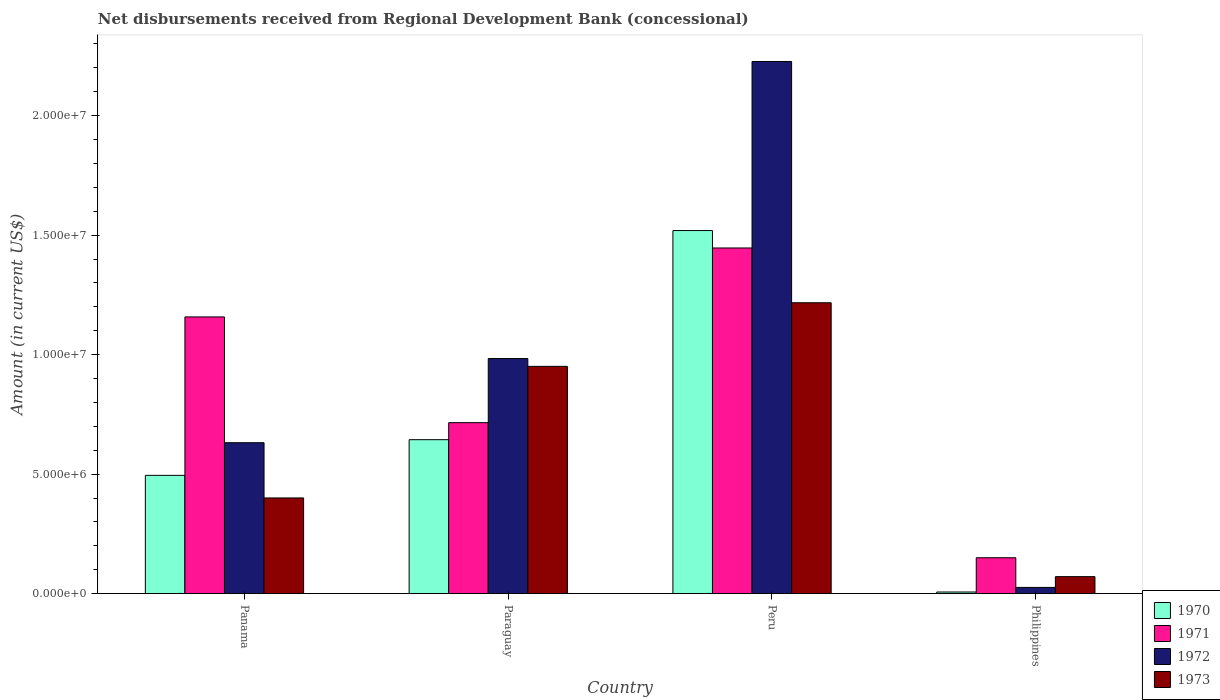How many different coloured bars are there?
Your response must be concise. 4. How many groups of bars are there?
Offer a very short reply. 4. Are the number of bars per tick equal to the number of legend labels?
Provide a short and direct response. Yes. Are the number of bars on each tick of the X-axis equal?
Make the answer very short. Yes. What is the label of the 1st group of bars from the left?
Ensure brevity in your answer.  Panama. What is the amount of disbursements received from Regional Development Bank in 1973 in Peru?
Offer a very short reply. 1.22e+07. Across all countries, what is the maximum amount of disbursements received from Regional Development Bank in 1973?
Your answer should be very brief. 1.22e+07. Across all countries, what is the minimum amount of disbursements received from Regional Development Bank in 1970?
Give a very brief answer. 6.90e+04. In which country was the amount of disbursements received from Regional Development Bank in 1970 maximum?
Your response must be concise. Peru. In which country was the amount of disbursements received from Regional Development Bank in 1971 minimum?
Provide a short and direct response. Philippines. What is the total amount of disbursements received from Regional Development Bank in 1972 in the graph?
Your answer should be very brief. 3.87e+07. What is the difference between the amount of disbursements received from Regional Development Bank in 1971 in Paraguay and that in Peru?
Keep it short and to the point. -7.31e+06. What is the difference between the amount of disbursements received from Regional Development Bank in 1972 in Paraguay and the amount of disbursements received from Regional Development Bank in 1973 in Peru?
Provide a short and direct response. -2.33e+06. What is the average amount of disbursements received from Regional Development Bank in 1972 per country?
Keep it short and to the point. 9.67e+06. What is the difference between the amount of disbursements received from Regional Development Bank of/in 1970 and amount of disbursements received from Regional Development Bank of/in 1971 in Paraguay?
Your answer should be very brief. -7.12e+05. In how many countries, is the amount of disbursements received from Regional Development Bank in 1970 greater than 10000000 US$?
Your answer should be very brief. 1. What is the ratio of the amount of disbursements received from Regional Development Bank in 1971 in Paraguay to that in Peru?
Keep it short and to the point. 0.49. Is the difference between the amount of disbursements received from Regional Development Bank in 1970 in Peru and Philippines greater than the difference between the amount of disbursements received from Regional Development Bank in 1971 in Peru and Philippines?
Provide a short and direct response. Yes. What is the difference between the highest and the second highest amount of disbursements received from Regional Development Bank in 1972?
Offer a very short reply. 1.60e+07. What is the difference between the highest and the lowest amount of disbursements received from Regional Development Bank in 1970?
Provide a succinct answer. 1.51e+07. In how many countries, is the amount of disbursements received from Regional Development Bank in 1970 greater than the average amount of disbursements received from Regional Development Bank in 1970 taken over all countries?
Your response must be concise. 1. Is it the case that in every country, the sum of the amount of disbursements received from Regional Development Bank in 1970 and amount of disbursements received from Regional Development Bank in 1972 is greater than the sum of amount of disbursements received from Regional Development Bank in 1971 and amount of disbursements received from Regional Development Bank in 1973?
Give a very brief answer. No. What does the 2nd bar from the left in Panama represents?
Your answer should be compact. 1971. What does the 4th bar from the right in Paraguay represents?
Keep it short and to the point. 1970. How many bars are there?
Ensure brevity in your answer.  16. Are all the bars in the graph horizontal?
Your answer should be compact. No. Does the graph contain any zero values?
Give a very brief answer. No. Where does the legend appear in the graph?
Offer a very short reply. Bottom right. What is the title of the graph?
Offer a terse response. Net disbursements received from Regional Development Bank (concessional). Does "1974" appear as one of the legend labels in the graph?
Offer a very short reply. No. What is the label or title of the X-axis?
Make the answer very short. Country. What is the label or title of the Y-axis?
Your answer should be compact. Amount (in current US$). What is the Amount (in current US$) in 1970 in Panama?
Your answer should be compact. 4.95e+06. What is the Amount (in current US$) of 1971 in Panama?
Offer a very short reply. 1.16e+07. What is the Amount (in current US$) in 1972 in Panama?
Make the answer very short. 6.32e+06. What is the Amount (in current US$) in 1973 in Panama?
Provide a succinct answer. 4.00e+06. What is the Amount (in current US$) in 1970 in Paraguay?
Make the answer very short. 6.44e+06. What is the Amount (in current US$) in 1971 in Paraguay?
Provide a succinct answer. 7.16e+06. What is the Amount (in current US$) of 1972 in Paraguay?
Keep it short and to the point. 9.84e+06. What is the Amount (in current US$) of 1973 in Paraguay?
Offer a very short reply. 9.51e+06. What is the Amount (in current US$) of 1970 in Peru?
Provide a succinct answer. 1.52e+07. What is the Amount (in current US$) of 1971 in Peru?
Make the answer very short. 1.45e+07. What is the Amount (in current US$) of 1972 in Peru?
Offer a terse response. 2.23e+07. What is the Amount (in current US$) of 1973 in Peru?
Offer a very short reply. 1.22e+07. What is the Amount (in current US$) of 1970 in Philippines?
Your answer should be compact. 6.90e+04. What is the Amount (in current US$) in 1971 in Philippines?
Provide a succinct answer. 1.50e+06. What is the Amount (in current US$) in 1972 in Philippines?
Your answer should be compact. 2.61e+05. What is the Amount (in current US$) in 1973 in Philippines?
Give a very brief answer. 7.12e+05. Across all countries, what is the maximum Amount (in current US$) in 1970?
Keep it short and to the point. 1.52e+07. Across all countries, what is the maximum Amount (in current US$) in 1971?
Offer a very short reply. 1.45e+07. Across all countries, what is the maximum Amount (in current US$) in 1972?
Provide a short and direct response. 2.23e+07. Across all countries, what is the maximum Amount (in current US$) of 1973?
Give a very brief answer. 1.22e+07. Across all countries, what is the minimum Amount (in current US$) of 1970?
Your response must be concise. 6.90e+04. Across all countries, what is the minimum Amount (in current US$) of 1971?
Offer a terse response. 1.50e+06. Across all countries, what is the minimum Amount (in current US$) in 1972?
Provide a short and direct response. 2.61e+05. Across all countries, what is the minimum Amount (in current US$) of 1973?
Your response must be concise. 7.12e+05. What is the total Amount (in current US$) of 1970 in the graph?
Make the answer very short. 2.67e+07. What is the total Amount (in current US$) of 1971 in the graph?
Ensure brevity in your answer.  3.47e+07. What is the total Amount (in current US$) of 1972 in the graph?
Provide a succinct answer. 3.87e+07. What is the total Amount (in current US$) in 1973 in the graph?
Give a very brief answer. 2.64e+07. What is the difference between the Amount (in current US$) in 1970 in Panama and that in Paraguay?
Keep it short and to the point. -1.49e+06. What is the difference between the Amount (in current US$) in 1971 in Panama and that in Paraguay?
Ensure brevity in your answer.  4.42e+06. What is the difference between the Amount (in current US$) of 1972 in Panama and that in Paraguay?
Offer a very short reply. -3.52e+06. What is the difference between the Amount (in current US$) in 1973 in Panama and that in Paraguay?
Provide a short and direct response. -5.50e+06. What is the difference between the Amount (in current US$) of 1970 in Panama and that in Peru?
Make the answer very short. -1.02e+07. What is the difference between the Amount (in current US$) of 1971 in Panama and that in Peru?
Offer a terse response. -2.88e+06. What is the difference between the Amount (in current US$) in 1972 in Panama and that in Peru?
Offer a very short reply. -1.60e+07. What is the difference between the Amount (in current US$) of 1973 in Panama and that in Peru?
Ensure brevity in your answer.  -8.17e+06. What is the difference between the Amount (in current US$) in 1970 in Panama and that in Philippines?
Your response must be concise. 4.88e+06. What is the difference between the Amount (in current US$) of 1971 in Panama and that in Philippines?
Your response must be concise. 1.01e+07. What is the difference between the Amount (in current US$) of 1972 in Panama and that in Philippines?
Your response must be concise. 6.06e+06. What is the difference between the Amount (in current US$) of 1973 in Panama and that in Philippines?
Ensure brevity in your answer.  3.29e+06. What is the difference between the Amount (in current US$) of 1970 in Paraguay and that in Peru?
Provide a succinct answer. -8.75e+06. What is the difference between the Amount (in current US$) in 1971 in Paraguay and that in Peru?
Your answer should be compact. -7.31e+06. What is the difference between the Amount (in current US$) in 1972 in Paraguay and that in Peru?
Keep it short and to the point. -1.24e+07. What is the difference between the Amount (in current US$) in 1973 in Paraguay and that in Peru?
Your answer should be very brief. -2.66e+06. What is the difference between the Amount (in current US$) of 1970 in Paraguay and that in Philippines?
Your response must be concise. 6.37e+06. What is the difference between the Amount (in current US$) of 1971 in Paraguay and that in Philippines?
Your answer should be compact. 5.65e+06. What is the difference between the Amount (in current US$) of 1972 in Paraguay and that in Philippines?
Offer a very short reply. 9.58e+06. What is the difference between the Amount (in current US$) in 1973 in Paraguay and that in Philippines?
Your answer should be very brief. 8.80e+06. What is the difference between the Amount (in current US$) in 1970 in Peru and that in Philippines?
Make the answer very short. 1.51e+07. What is the difference between the Amount (in current US$) of 1971 in Peru and that in Philippines?
Your answer should be compact. 1.30e+07. What is the difference between the Amount (in current US$) in 1972 in Peru and that in Philippines?
Offer a terse response. 2.20e+07. What is the difference between the Amount (in current US$) in 1973 in Peru and that in Philippines?
Offer a terse response. 1.15e+07. What is the difference between the Amount (in current US$) in 1970 in Panama and the Amount (in current US$) in 1971 in Paraguay?
Your answer should be very brief. -2.20e+06. What is the difference between the Amount (in current US$) of 1970 in Panama and the Amount (in current US$) of 1972 in Paraguay?
Keep it short and to the point. -4.89e+06. What is the difference between the Amount (in current US$) of 1970 in Panama and the Amount (in current US$) of 1973 in Paraguay?
Offer a terse response. -4.56e+06. What is the difference between the Amount (in current US$) in 1971 in Panama and the Amount (in current US$) in 1972 in Paraguay?
Offer a terse response. 1.74e+06. What is the difference between the Amount (in current US$) in 1971 in Panama and the Amount (in current US$) in 1973 in Paraguay?
Give a very brief answer. 2.07e+06. What is the difference between the Amount (in current US$) in 1972 in Panama and the Amount (in current US$) in 1973 in Paraguay?
Offer a very short reply. -3.19e+06. What is the difference between the Amount (in current US$) in 1970 in Panama and the Amount (in current US$) in 1971 in Peru?
Your response must be concise. -9.51e+06. What is the difference between the Amount (in current US$) of 1970 in Panama and the Amount (in current US$) of 1972 in Peru?
Your answer should be very brief. -1.73e+07. What is the difference between the Amount (in current US$) of 1970 in Panama and the Amount (in current US$) of 1973 in Peru?
Your answer should be very brief. -7.22e+06. What is the difference between the Amount (in current US$) of 1971 in Panama and the Amount (in current US$) of 1972 in Peru?
Your answer should be very brief. -1.07e+07. What is the difference between the Amount (in current US$) in 1971 in Panama and the Amount (in current US$) in 1973 in Peru?
Ensure brevity in your answer.  -5.93e+05. What is the difference between the Amount (in current US$) of 1972 in Panama and the Amount (in current US$) of 1973 in Peru?
Give a very brief answer. -5.86e+06. What is the difference between the Amount (in current US$) of 1970 in Panama and the Amount (in current US$) of 1971 in Philippines?
Your response must be concise. 3.45e+06. What is the difference between the Amount (in current US$) of 1970 in Panama and the Amount (in current US$) of 1972 in Philippines?
Your answer should be very brief. 4.69e+06. What is the difference between the Amount (in current US$) of 1970 in Panama and the Amount (in current US$) of 1973 in Philippines?
Provide a succinct answer. 4.24e+06. What is the difference between the Amount (in current US$) in 1971 in Panama and the Amount (in current US$) in 1972 in Philippines?
Provide a short and direct response. 1.13e+07. What is the difference between the Amount (in current US$) of 1971 in Panama and the Amount (in current US$) of 1973 in Philippines?
Make the answer very short. 1.09e+07. What is the difference between the Amount (in current US$) in 1972 in Panama and the Amount (in current US$) in 1973 in Philippines?
Provide a succinct answer. 5.60e+06. What is the difference between the Amount (in current US$) of 1970 in Paraguay and the Amount (in current US$) of 1971 in Peru?
Offer a terse response. -8.02e+06. What is the difference between the Amount (in current US$) in 1970 in Paraguay and the Amount (in current US$) in 1972 in Peru?
Ensure brevity in your answer.  -1.58e+07. What is the difference between the Amount (in current US$) in 1970 in Paraguay and the Amount (in current US$) in 1973 in Peru?
Offer a terse response. -5.73e+06. What is the difference between the Amount (in current US$) in 1971 in Paraguay and the Amount (in current US$) in 1972 in Peru?
Your response must be concise. -1.51e+07. What is the difference between the Amount (in current US$) in 1971 in Paraguay and the Amount (in current US$) in 1973 in Peru?
Offer a very short reply. -5.02e+06. What is the difference between the Amount (in current US$) in 1972 in Paraguay and the Amount (in current US$) in 1973 in Peru?
Your answer should be very brief. -2.33e+06. What is the difference between the Amount (in current US$) in 1970 in Paraguay and the Amount (in current US$) in 1971 in Philippines?
Your answer should be compact. 4.94e+06. What is the difference between the Amount (in current US$) in 1970 in Paraguay and the Amount (in current US$) in 1972 in Philippines?
Give a very brief answer. 6.18e+06. What is the difference between the Amount (in current US$) in 1970 in Paraguay and the Amount (in current US$) in 1973 in Philippines?
Ensure brevity in your answer.  5.73e+06. What is the difference between the Amount (in current US$) of 1971 in Paraguay and the Amount (in current US$) of 1972 in Philippines?
Your response must be concise. 6.89e+06. What is the difference between the Amount (in current US$) of 1971 in Paraguay and the Amount (in current US$) of 1973 in Philippines?
Provide a succinct answer. 6.44e+06. What is the difference between the Amount (in current US$) in 1972 in Paraguay and the Amount (in current US$) in 1973 in Philippines?
Your answer should be very brief. 9.13e+06. What is the difference between the Amount (in current US$) in 1970 in Peru and the Amount (in current US$) in 1971 in Philippines?
Your answer should be very brief. 1.37e+07. What is the difference between the Amount (in current US$) of 1970 in Peru and the Amount (in current US$) of 1972 in Philippines?
Provide a short and direct response. 1.49e+07. What is the difference between the Amount (in current US$) of 1970 in Peru and the Amount (in current US$) of 1973 in Philippines?
Ensure brevity in your answer.  1.45e+07. What is the difference between the Amount (in current US$) of 1971 in Peru and the Amount (in current US$) of 1972 in Philippines?
Your response must be concise. 1.42e+07. What is the difference between the Amount (in current US$) in 1971 in Peru and the Amount (in current US$) in 1973 in Philippines?
Your answer should be compact. 1.38e+07. What is the difference between the Amount (in current US$) of 1972 in Peru and the Amount (in current US$) of 1973 in Philippines?
Offer a terse response. 2.16e+07. What is the average Amount (in current US$) in 1970 per country?
Give a very brief answer. 6.66e+06. What is the average Amount (in current US$) of 1971 per country?
Ensure brevity in your answer.  8.68e+06. What is the average Amount (in current US$) in 1972 per country?
Make the answer very short. 9.67e+06. What is the average Amount (in current US$) of 1973 per country?
Give a very brief answer. 6.60e+06. What is the difference between the Amount (in current US$) of 1970 and Amount (in current US$) of 1971 in Panama?
Keep it short and to the point. -6.63e+06. What is the difference between the Amount (in current US$) in 1970 and Amount (in current US$) in 1972 in Panama?
Ensure brevity in your answer.  -1.37e+06. What is the difference between the Amount (in current US$) of 1970 and Amount (in current US$) of 1973 in Panama?
Ensure brevity in your answer.  9.45e+05. What is the difference between the Amount (in current US$) of 1971 and Amount (in current US$) of 1972 in Panama?
Keep it short and to the point. 5.26e+06. What is the difference between the Amount (in current US$) of 1971 and Amount (in current US$) of 1973 in Panama?
Provide a short and direct response. 7.57e+06. What is the difference between the Amount (in current US$) in 1972 and Amount (in current US$) in 1973 in Panama?
Make the answer very short. 2.31e+06. What is the difference between the Amount (in current US$) in 1970 and Amount (in current US$) in 1971 in Paraguay?
Your answer should be very brief. -7.12e+05. What is the difference between the Amount (in current US$) of 1970 and Amount (in current US$) of 1972 in Paraguay?
Provide a succinct answer. -3.40e+06. What is the difference between the Amount (in current US$) in 1970 and Amount (in current US$) in 1973 in Paraguay?
Provide a succinct answer. -3.07e+06. What is the difference between the Amount (in current US$) in 1971 and Amount (in current US$) in 1972 in Paraguay?
Provide a succinct answer. -2.68e+06. What is the difference between the Amount (in current US$) of 1971 and Amount (in current US$) of 1973 in Paraguay?
Offer a terse response. -2.36e+06. What is the difference between the Amount (in current US$) in 1972 and Amount (in current US$) in 1973 in Paraguay?
Ensure brevity in your answer.  3.28e+05. What is the difference between the Amount (in current US$) of 1970 and Amount (in current US$) of 1971 in Peru?
Your response must be concise. 7.29e+05. What is the difference between the Amount (in current US$) of 1970 and Amount (in current US$) of 1972 in Peru?
Your response must be concise. -7.07e+06. What is the difference between the Amount (in current US$) of 1970 and Amount (in current US$) of 1973 in Peru?
Your answer should be compact. 3.02e+06. What is the difference between the Amount (in current US$) in 1971 and Amount (in current US$) in 1972 in Peru?
Offer a very short reply. -7.80e+06. What is the difference between the Amount (in current US$) in 1971 and Amount (in current US$) in 1973 in Peru?
Give a very brief answer. 2.29e+06. What is the difference between the Amount (in current US$) in 1972 and Amount (in current US$) in 1973 in Peru?
Offer a very short reply. 1.01e+07. What is the difference between the Amount (in current US$) of 1970 and Amount (in current US$) of 1971 in Philippines?
Make the answer very short. -1.43e+06. What is the difference between the Amount (in current US$) in 1970 and Amount (in current US$) in 1972 in Philippines?
Give a very brief answer. -1.92e+05. What is the difference between the Amount (in current US$) in 1970 and Amount (in current US$) in 1973 in Philippines?
Provide a short and direct response. -6.43e+05. What is the difference between the Amount (in current US$) in 1971 and Amount (in current US$) in 1972 in Philippines?
Provide a short and direct response. 1.24e+06. What is the difference between the Amount (in current US$) of 1971 and Amount (in current US$) of 1973 in Philippines?
Give a very brief answer. 7.91e+05. What is the difference between the Amount (in current US$) in 1972 and Amount (in current US$) in 1973 in Philippines?
Ensure brevity in your answer.  -4.51e+05. What is the ratio of the Amount (in current US$) in 1970 in Panama to that in Paraguay?
Keep it short and to the point. 0.77. What is the ratio of the Amount (in current US$) of 1971 in Panama to that in Paraguay?
Offer a very short reply. 1.62. What is the ratio of the Amount (in current US$) in 1972 in Panama to that in Paraguay?
Provide a succinct answer. 0.64. What is the ratio of the Amount (in current US$) of 1973 in Panama to that in Paraguay?
Provide a succinct answer. 0.42. What is the ratio of the Amount (in current US$) of 1970 in Panama to that in Peru?
Offer a very short reply. 0.33. What is the ratio of the Amount (in current US$) in 1971 in Panama to that in Peru?
Provide a short and direct response. 0.8. What is the ratio of the Amount (in current US$) of 1972 in Panama to that in Peru?
Provide a short and direct response. 0.28. What is the ratio of the Amount (in current US$) of 1973 in Panama to that in Peru?
Your answer should be very brief. 0.33. What is the ratio of the Amount (in current US$) in 1970 in Panama to that in Philippines?
Provide a succinct answer. 71.74. What is the ratio of the Amount (in current US$) of 1971 in Panama to that in Philippines?
Provide a short and direct response. 7.7. What is the ratio of the Amount (in current US$) in 1972 in Panama to that in Philippines?
Provide a succinct answer. 24.2. What is the ratio of the Amount (in current US$) of 1973 in Panama to that in Philippines?
Give a very brief answer. 5.62. What is the ratio of the Amount (in current US$) of 1970 in Paraguay to that in Peru?
Make the answer very short. 0.42. What is the ratio of the Amount (in current US$) of 1971 in Paraguay to that in Peru?
Your response must be concise. 0.49. What is the ratio of the Amount (in current US$) of 1972 in Paraguay to that in Peru?
Ensure brevity in your answer.  0.44. What is the ratio of the Amount (in current US$) of 1973 in Paraguay to that in Peru?
Provide a succinct answer. 0.78. What is the ratio of the Amount (in current US$) of 1970 in Paraguay to that in Philippines?
Provide a short and direct response. 93.38. What is the ratio of the Amount (in current US$) of 1971 in Paraguay to that in Philippines?
Your answer should be very brief. 4.76. What is the ratio of the Amount (in current US$) in 1972 in Paraguay to that in Philippines?
Provide a short and direct response. 37.69. What is the ratio of the Amount (in current US$) of 1973 in Paraguay to that in Philippines?
Give a very brief answer. 13.36. What is the ratio of the Amount (in current US$) in 1970 in Peru to that in Philippines?
Offer a very short reply. 220.19. What is the ratio of the Amount (in current US$) of 1971 in Peru to that in Philippines?
Provide a succinct answer. 9.62. What is the ratio of the Amount (in current US$) of 1972 in Peru to that in Philippines?
Offer a very short reply. 85.31. What is the ratio of the Amount (in current US$) of 1973 in Peru to that in Philippines?
Offer a very short reply. 17.1. What is the difference between the highest and the second highest Amount (in current US$) of 1970?
Keep it short and to the point. 8.75e+06. What is the difference between the highest and the second highest Amount (in current US$) of 1971?
Provide a succinct answer. 2.88e+06. What is the difference between the highest and the second highest Amount (in current US$) in 1972?
Offer a very short reply. 1.24e+07. What is the difference between the highest and the second highest Amount (in current US$) of 1973?
Offer a terse response. 2.66e+06. What is the difference between the highest and the lowest Amount (in current US$) in 1970?
Ensure brevity in your answer.  1.51e+07. What is the difference between the highest and the lowest Amount (in current US$) of 1971?
Provide a short and direct response. 1.30e+07. What is the difference between the highest and the lowest Amount (in current US$) of 1972?
Ensure brevity in your answer.  2.20e+07. What is the difference between the highest and the lowest Amount (in current US$) of 1973?
Your answer should be compact. 1.15e+07. 